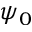<formula> <loc_0><loc_0><loc_500><loc_500>\psi _ { 0 }</formula> 